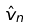Convert formula to latex. <formula><loc_0><loc_0><loc_500><loc_500>\hat { v } _ { n }</formula> 